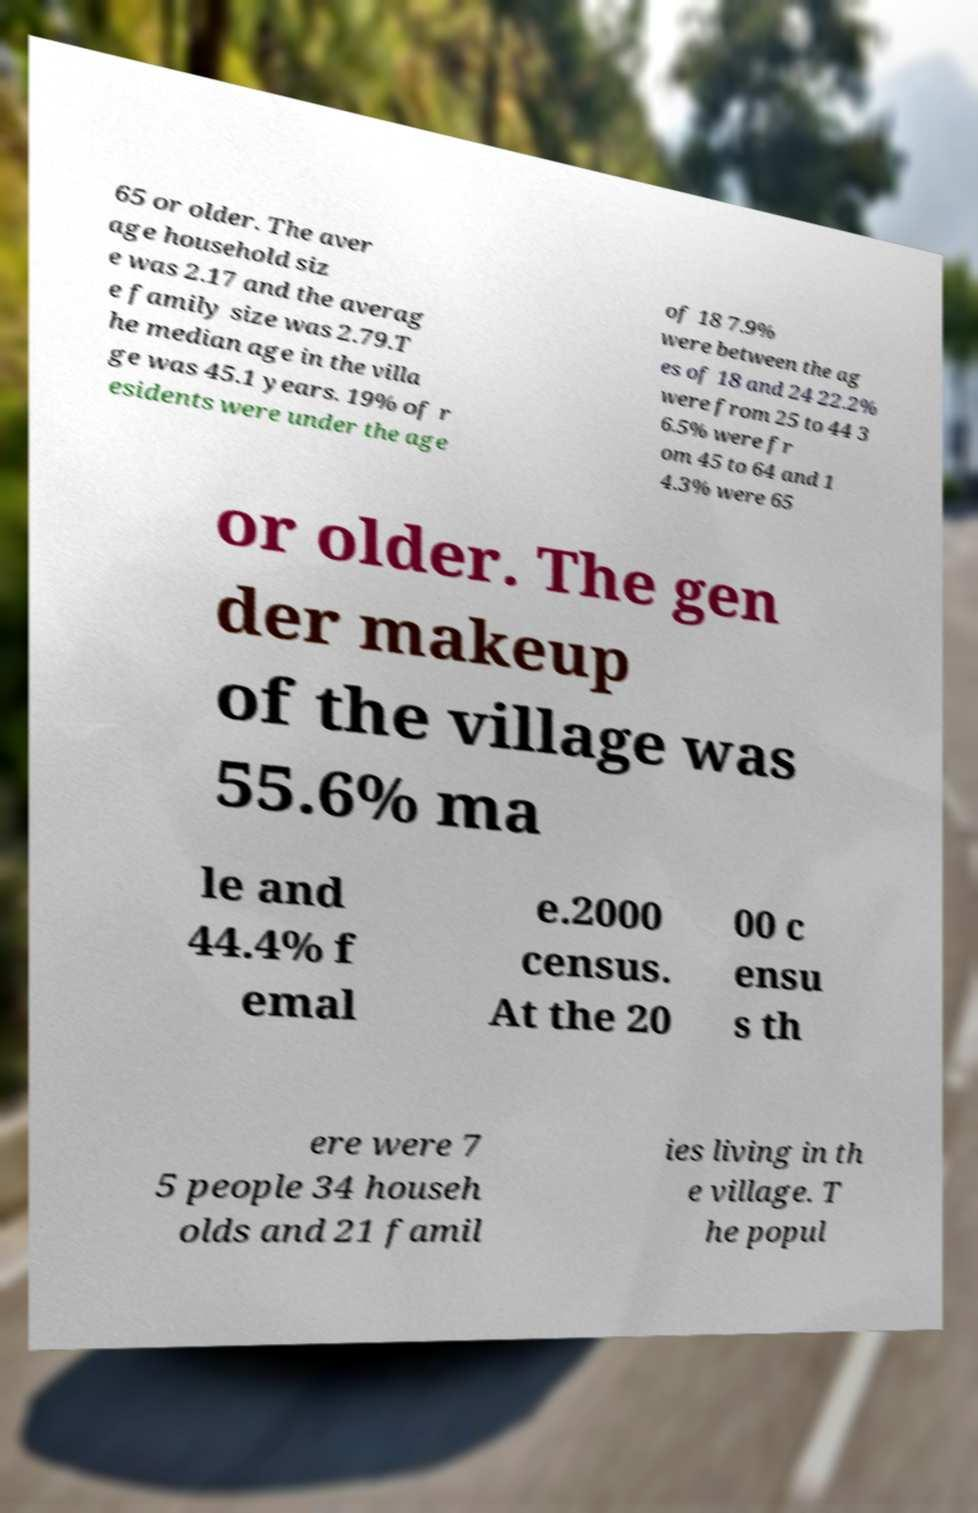I need the written content from this picture converted into text. Can you do that? 65 or older. The aver age household siz e was 2.17 and the averag e family size was 2.79.T he median age in the villa ge was 45.1 years. 19% of r esidents were under the age of 18 7.9% were between the ag es of 18 and 24 22.2% were from 25 to 44 3 6.5% were fr om 45 to 64 and 1 4.3% were 65 or older. The gen der makeup of the village was 55.6% ma le and 44.4% f emal e.2000 census. At the 20 00 c ensu s th ere were 7 5 people 34 househ olds and 21 famil ies living in th e village. T he popul 